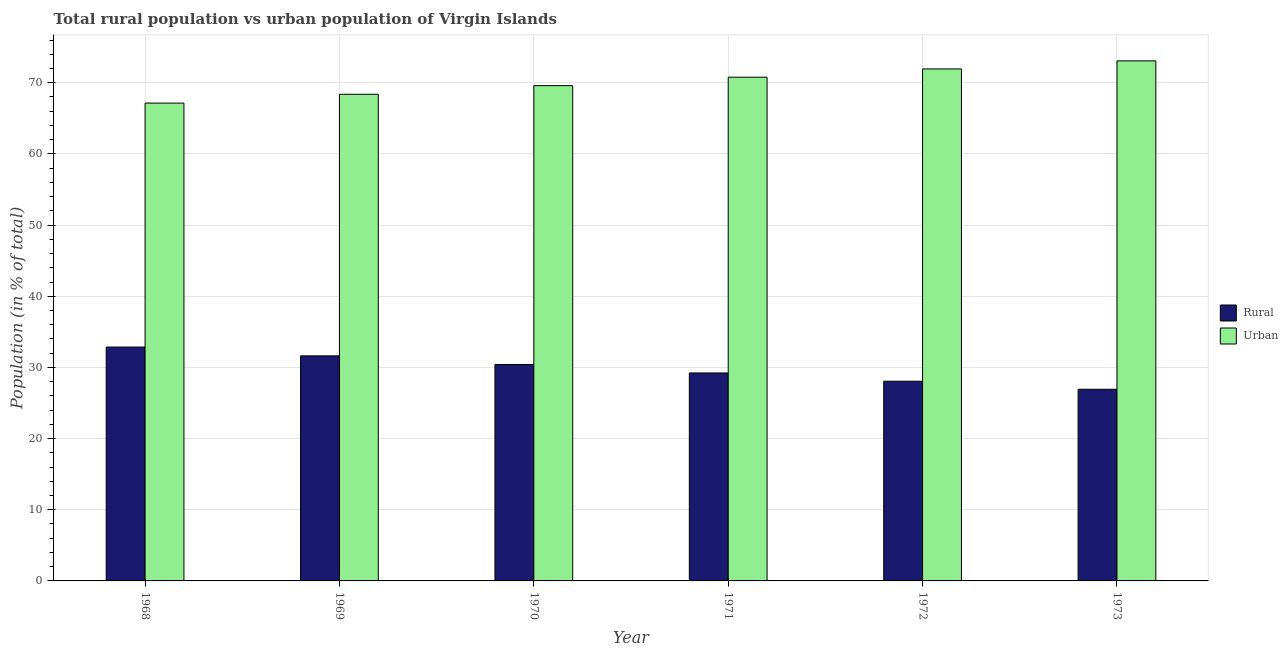How many groups of bars are there?
Provide a succinct answer. 6. How many bars are there on the 3rd tick from the left?
Offer a terse response. 2. What is the label of the 4th group of bars from the left?
Give a very brief answer. 1971. In how many cases, is the number of bars for a given year not equal to the number of legend labels?
Give a very brief answer. 0. What is the urban population in 1970?
Give a very brief answer. 69.59. Across all years, what is the maximum urban population?
Provide a short and direct response. 73.07. Across all years, what is the minimum urban population?
Provide a short and direct response. 67.14. In which year was the urban population maximum?
Offer a terse response. 1973. In which year was the urban population minimum?
Your response must be concise. 1968. What is the total rural population in the graph?
Your response must be concise. 179.1. What is the difference between the urban population in 1972 and that in 1973?
Offer a very short reply. -1.13. What is the difference between the rural population in 1971 and the urban population in 1968?
Offer a terse response. -3.64. What is the average rural population per year?
Your answer should be very brief. 29.85. What is the ratio of the urban population in 1969 to that in 1970?
Your answer should be compact. 0.98. Is the difference between the rural population in 1968 and 1970 greater than the difference between the urban population in 1968 and 1970?
Offer a very short reply. No. What is the difference between the highest and the second highest urban population?
Keep it short and to the point. 1.13. What is the difference between the highest and the lowest urban population?
Ensure brevity in your answer.  5.93. In how many years, is the rural population greater than the average rural population taken over all years?
Provide a short and direct response. 3. What does the 2nd bar from the left in 1971 represents?
Your response must be concise. Urban. What does the 2nd bar from the right in 1968 represents?
Your response must be concise. Rural. How many years are there in the graph?
Make the answer very short. 6. Are the values on the major ticks of Y-axis written in scientific E-notation?
Make the answer very short. No. Does the graph contain grids?
Provide a succinct answer. Yes. Where does the legend appear in the graph?
Keep it short and to the point. Center right. How many legend labels are there?
Your answer should be compact. 2. How are the legend labels stacked?
Ensure brevity in your answer.  Vertical. What is the title of the graph?
Keep it short and to the point. Total rural population vs urban population of Virgin Islands. Does "Female" appear as one of the legend labels in the graph?
Your answer should be very brief. No. What is the label or title of the X-axis?
Ensure brevity in your answer.  Year. What is the label or title of the Y-axis?
Make the answer very short. Population (in % of total). What is the Population (in % of total) in Rural in 1968?
Keep it short and to the point. 32.86. What is the Population (in % of total) of Urban in 1968?
Your answer should be compact. 67.14. What is the Population (in % of total) of Rural in 1969?
Give a very brief answer. 31.62. What is the Population (in % of total) of Urban in 1969?
Your answer should be compact. 68.38. What is the Population (in % of total) of Rural in 1970?
Provide a short and direct response. 30.41. What is the Population (in % of total) of Urban in 1970?
Your answer should be compact. 69.59. What is the Population (in % of total) in Rural in 1971?
Your answer should be very brief. 29.22. What is the Population (in % of total) of Urban in 1971?
Provide a short and direct response. 70.78. What is the Population (in % of total) of Rural in 1972?
Keep it short and to the point. 28.06. What is the Population (in % of total) in Urban in 1972?
Offer a terse response. 71.94. What is the Population (in % of total) in Rural in 1973?
Give a very brief answer. 26.93. What is the Population (in % of total) in Urban in 1973?
Offer a terse response. 73.07. Across all years, what is the maximum Population (in % of total) of Rural?
Offer a terse response. 32.86. Across all years, what is the maximum Population (in % of total) of Urban?
Keep it short and to the point. 73.07. Across all years, what is the minimum Population (in % of total) in Rural?
Offer a very short reply. 26.93. Across all years, what is the minimum Population (in % of total) of Urban?
Your response must be concise. 67.14. What is the total Population (in % of total) in Rural in the graph?
Give a very brief answer. 179.1. What is the total Population (in % of total) in Urban in the graph?
Keep it short and to the point. 420.9. What is the difference between the Population (in % of total) of Rural in 1968 and that in 1969?
Your answer should be very brief. 1.24. What is the difference between the Population (in % of total) of Urban in 1968 and that in 1969?
Offer a very short reply. -1.24. What is the difference between the Population (in % of total) in Rural in 1968 and that in 1970?
Your answer should be very brief. 2.45. What is the difference between the Population (in % of total) of Urban in 1968 and that in 1970?
Your answer should be compact. -2.45. What is the difference between the Population (in % of total) of Rural in 1968 and that in 1971?
Provide a short and direct response. 3.64. What is the difference between the Population (in % of total) of Urban in 1968 and that in 1971?
Keep it short and to the point. -3.64. What is the difference between the Population (in % of total) of Rural in 1968 and that in 1972?
Your response must be concise. 4.8. What is the difference between the Population (in % of total) of Urban in 1968 and that in 1972?
Ensure brevity in your answer.  -4.8. What is the difference between the Population (in % of total) in Rural in 1968 and that in 1973?
Your answer should be compact. 5.93. What is the difference between the Population (in % of total) of Urban in 1968 and that in 1973?
Offer a terse response. -5.93. What is the difference between the Population (in % of total) in Rural in 1969 and that in 1970?
Keep it short and to the point. 1.21. What is the difference between the Population (in % of total) in Urban in 1969 and that in 1970?
Your response must be concise. -1.21. What is the difference between the Population (in % of total) of Rural in 1969 and that in 1971?
Keep it short and to the point. 2.4. What is the difference between the Population (in % of total) in Urban in 1969 and that in 1971?
Provide a succinct answer. -2.4. What is the difference between the Population (in % of total) in Rural in 1969 and that in 1972?
Make the answer very short. 3.56. What is the difference between the Population (in % of total) of Urban in 1969 and that in 1972?
Provide a short and direct response. -3.56. What is the difference between the Population (in % of total) of Rural in 1969 and that in 1973?
Your answer should be very brief. 4.69. What is the difference between the Population (in % of total) in Urban in 1969 and that in 1973?
Your answer should be very brief. -4.69. What is the difference between the Population (in % of total) in Rural in 1970 and that in 1971?
Offer a very short reply. 1.19. What is the difference between the Population (in % of total) in Urban in 1970 and that in 1971?
Offer a terse response. -1.19. What is the difference between the Population (in % of total) of Rural in 1970 and that in 1972?
Provide a short and direct response. 2.35. What is the difference between the Population (in % of total) in Urban in 1970 and that in 1972?
Offer a terse response. -2.35. What is the difference between the Population (in % of total) in Rural in 1970 and that in 1973?
Give a very brief answer. 3.48. What is the difference between the Population (in % of total) of Urban in 1970 and that in 1973?
Provide a succinct answer. -3.48. What is the difference between the Population (in % of total) in Rural in 1971 and that in 1972?
Your answer should be compact. 1.16. What is the difference between the Population (in % of total) in Urban in 1971 and that in 1972?
Keep it short and to the point. -1.16. What is the difference between the Population (in % of total) in Rural in 1971 and that in 1973?
Your answer should be very brief. 2.29. What is the difference between the Population (in % of total) of Urban in 1971 and that in 1973?
Offer a very short reply. -2.29. What is the difference between the Population (in % of total) in Rural in 1972 and that in 1973?
Your answer should be very brief. 1.13. What is the difference between the Population (in % of total) of Urban in 1972 and that in 1973?
Your response must be concise. -1.13. What is the difference between the Population (in % of total) in Rural in 1968 and the Population (in % of total) in Urban in 1969?
Give a very brief answer. -35.52. What is the difference between the Population (in % of total) in Rural in 1968 and the Population (in % of total) in Urban in 1970?
Give a very brief answer. -36.73. What is the difference between the Population (in % of total) in Rural in 1968 and the Population (in % of total) in Urban in 1971?
Provide a succinct answer. -37.92. What is the difference between the Population (in % of total) in Rural in 1968 and the Population (in % of total) in Urban in 1972?
Offer a very short reply. -39.08. What is the difference between the Population (in % of total) of Rural in 1968 and the Population (in % of total) of Urban in 1973?
Your response must be concise. -40.21. What is the difference between the Population (in % of total) of Rural in 1969 and the Population (in % of total) of Urban in 1970?
Provide a short and direct response. -37.97. What is the difference between the Population (in % of total) in Rural in 1969 and the Population (in % of total) in Urban in 1971?
Provide a short and direct response. -39.16. What is the difference between the Population (in % of total) of Rural in 1969 and the Population (in % of total) of Urban in 1972?
Your answer should be very brief. -40.32. What is the difference between the Population (in % of total) of Rural in 1969 and the Population (in % of total) of Urban in 1973?
Make the answer very short. -41.45. What is the difference between the Population (in % of total) in Rural in 1970 and the Population (in % of total) in Urban in 1971?
Your answer should be compact. -40.37. What is the difference between the Population (in % of total) of Rural in 1970 and the Population (in % of total) of Urban in 1972?
Ensure brevity in your answer.  -41.53. What is the difference between the Population (in % of total) of Rural in 1970 and the Population (in % of total) of Urban in 1973?
Your answer should be very brief. -42.66. What is the difference between the Population (in % of total) in Rural in 1971 and the Population (in % of total) in Urban in 1972?
Your response must be concise. -42.72. What is the difference between the Population (in % of total) in Rural in 1971 and the Population (in % of total) in Urban in 1973?
Offer a terse response. -43.85. What is the difference between the Population (in % of total) in Rural in 1972 and the Population (in % of total) in Urban in 1973?
Ensure brevity in your answer.  -45.01. What is the average Population (in % of total) of Rural per year?
Give a very brief answer. 29.85. What is the average Population (in % of total) in Urban per year?
Your answer should be very brief. 70.15. In the year 1968, what is the difference between the Population (in % of total) in Rural and Population (in % of total) in Urban?
Your answer should be very brief. -34.28. In the year 1969, what is the difference between the Population (in % of total) in Rural and Population (in % of total) in Urban?
Offer a very short reply. -36.76. In the year 1970, what is the difference between the Population (in % of total) of Rural and Population (in % of total) of Urban?
Ensure brevity in your answer.  -39.18. In the year 1971, what is the difference between the Population (in % of total) of Rural and Population (in % of total) of Urban?
Offer a terse response. -41.56. In the year 1972, what is the difference between the Population (in % of total) in Rural and Population (in % of total) in Urban?
Keep it short and to the point. -43.88. In the year 1973, what is the difference between the Population (in % of total) of Rural and Population (in % of total) of Urban?
Give a very brief answer. -46.14. What is the ratio of the Population (in % of total) in Rural in 1968 to that in 1969?
Your answer should be compact. 1.04. What is the ratio of the Population (in % of total) in Urban in 1968 to that in 1969?
Offer a very short reply. 0.98. What is the ratio of the Population (in % of total) in Rural in 1968 to that in 1970?
Provide a succinct answer. 1.08. What is the ratio of the Population (in % of total) of Urban in 1968 to that in 1970?
Keep it short and to the point. 0.96. What is the ratio of the Population (in % of total) of Rural in 1968 to that in 1971?
Ensure brevity in your answer.  1.12. What is the ratio of the Population (in % of total) of Urban in 1968 to that in 1971?
Your response must be concise. 0.95. What is the ratio of the Population (in % of total) of Rural in 1968 to that in 1972?
Your response must be concise. 1.17. What is the ratio of the Population (in % of total) of Rural in 1968 to that in 1973?
Make the answer very short. 1.22. What is the ratio of the Population (in % of total) of Urban in 1968 to that in 1973?
Keep it short and to the point. 0.92. What is the ratio of the Population (in % of total) in Rural in 1969 to that in 1970?
Your answer should be compact. 1.04. What is the ratio of the Population (in % of total) in Urban in 1969 to that in 1970?
Your answer should be very brief. 0.98. What is the ratio of the Population (in % of total) in Rural in 1969 to that in 1971?
Make the answer very short. 1.08. What is the ratio of the Population (in % of total) in Urban in 1969 to that in 1971?
Make the answer very short. 0.97. What is the ratio of the Population (in % of total) in Rural in 1969 to that in 1972?
Keep it short and to the point. 1.13. What is the ratio of the Population (in % of total) of Urban in 1969 to that in 1972?
Provide a succinct answer. 0.95. What is the ratio of the Population (in % of total) of Rural in 1969 to that in 1973?
Provide a succinct answer. 1.17. What is the ratio of the Population (in % of total) in Urban in 1969 to that in 1973?
Give a very brief answer. 0.94. What is the ratio of the Population (in % of total) of Rural in 1970 to that in 1971?
Provide a succinct answer. 1.04. What is the ratio of the Population (in % of total) of Urban in 1970 to that in 1971?
Offer a terse response. 0.98. What is the ratio of the Population (in % of total) in Rural in 1970 to that in 1972?
Your answer should be compact. 1.08. What is the ratio of the Population (in % of total) in Urban in 1970 to that in 1972?
Offer a very short reply. 0.97. What is the ratio of the Population (in % of total) in Rural in 1970 to that in 1973?
Provide a succinct answer. 1.13. What is the ratio of the Population (in % of total) in Urban in 1970 to that in 1973?
Your answer should be very brief. 0.95. What is the ratio of the Population (in % of total) in Rural in 1971 to that in 1972?
Ensure brevity in your answer.  1.04. What is the ratio of the Population (in % of total) of Urban in 1971 to that in 1972?
Offer a very short reply. 0.98. What is the ratio of the Population (in % of total) of Rural in 1971 to that in 1973?
Keep it short and to the point. 1.09. What is the ratio of the Population (in % of total) in Urban in 1971 to that in 1973?
Your answer should be very brief. 0.97. What is the ratio of the Population (in % of total) of Rural in 1972 to that in 1973?
Ensure brevity in your answer.  1.04. What is the ratio of the Population (in % of total) in Urban in 1972 to that in 1973?
Offer a very short reply. 0.98. What is the difference between the highest and the second highest Population (in % of total) in Rural?
Keep it short and to the point. 1.24. What is the difference between the highest and the second highest Population (in % of total) of Urban?
Ensure brevity in your answer.  1.13. What is the difference between the highest and the lowest Population (in % of total) of Rural?
Keep it short and to the point. 5.93. What is the difference between the highest and the lowest Population (in % of total) in Urban?
Provide a short and direct response. 5.93. 